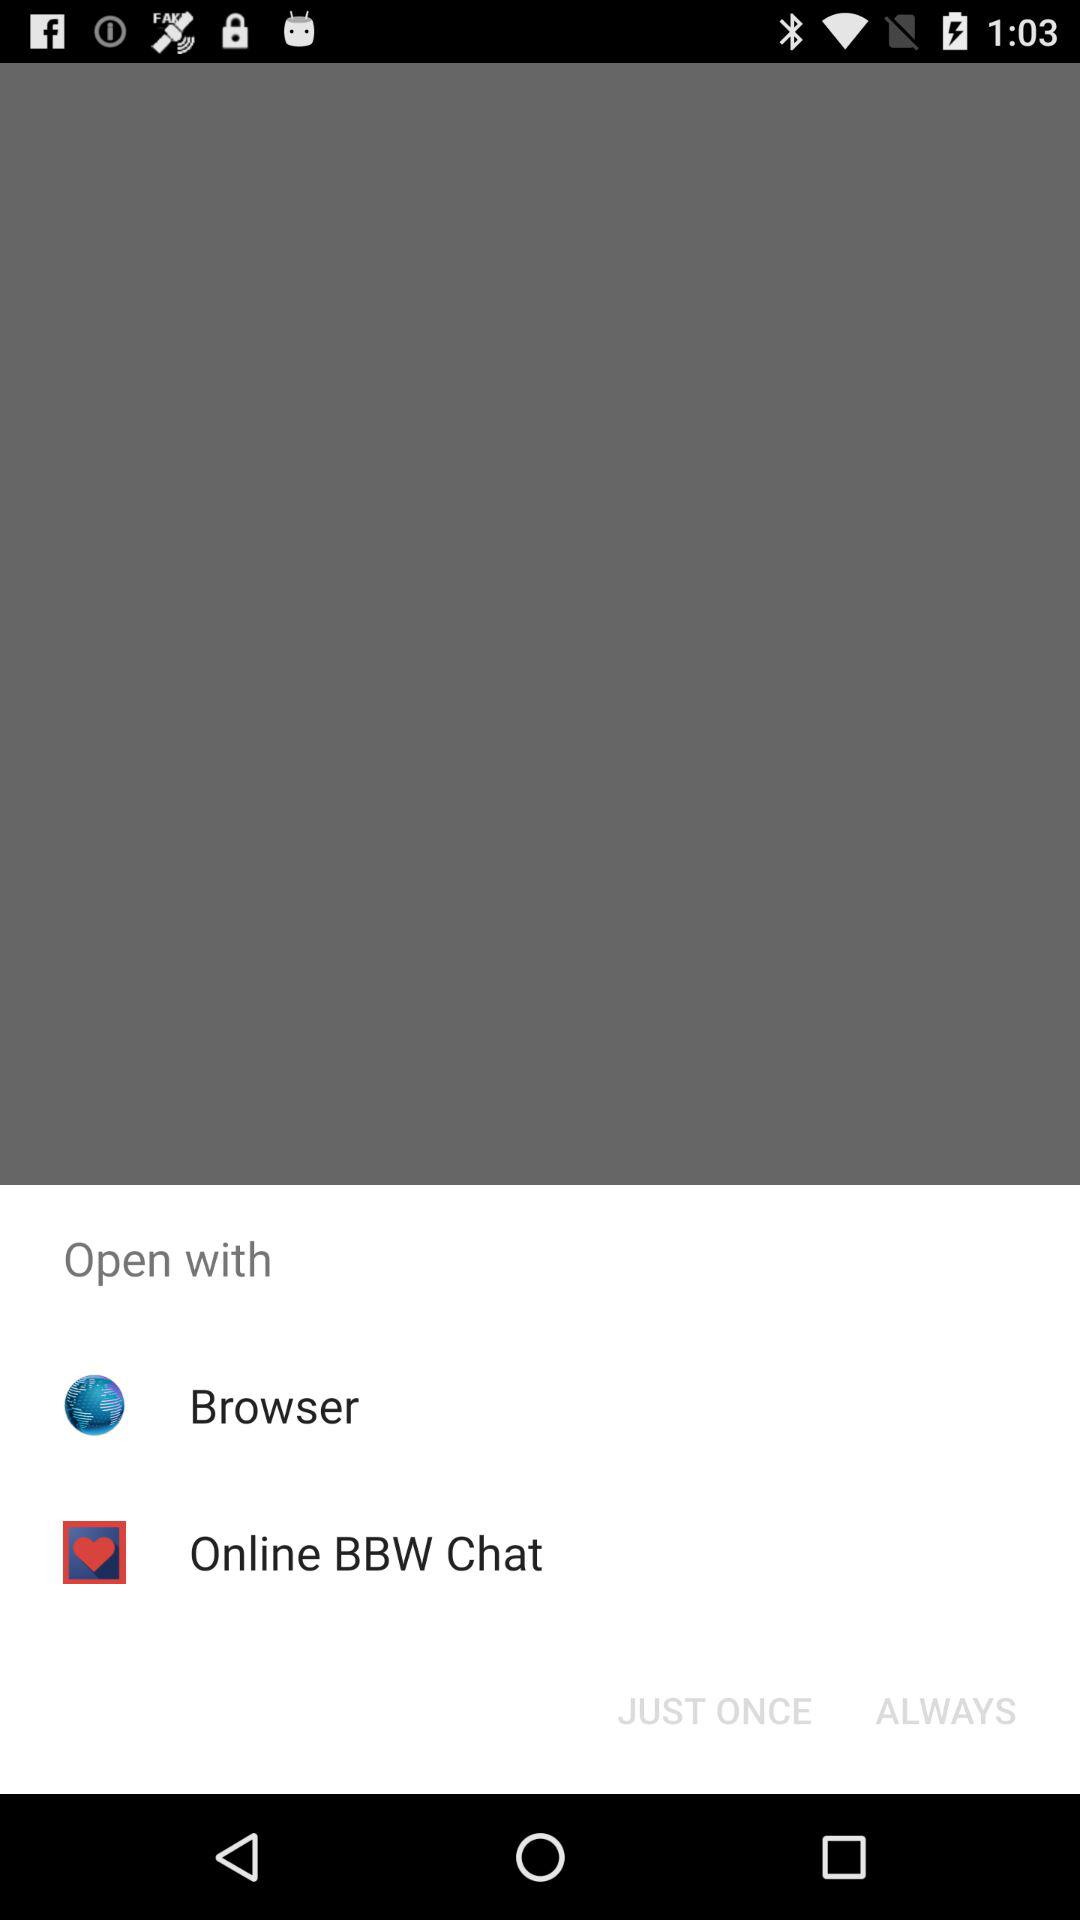What are the different options available for opening? The different options are "Browser" and "Online BBW Chat". 